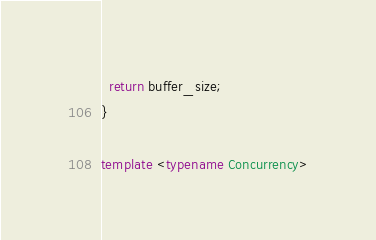Convert code to text. <code><loc_0><loc_0><loc_500><loc_500><_C++_>
  return buffer_size;
}

template <typename Concurrency></code> 